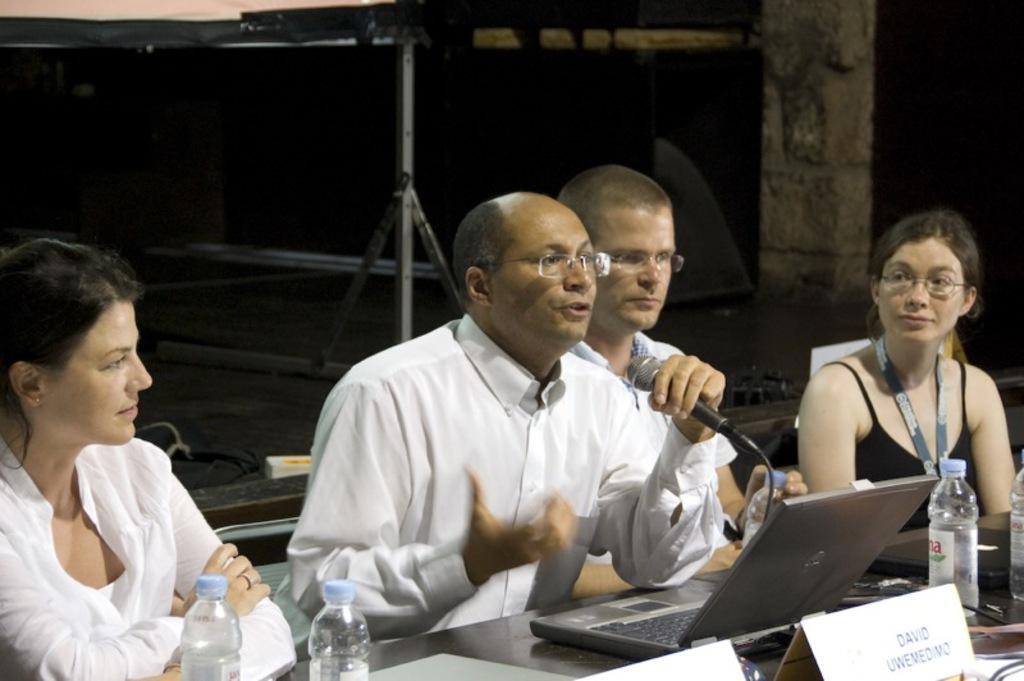Could you give a brief overview of what you see in this image? In this picture, we see four people sitting on chair. Among them, two are men and the remaining two are women. The man in the middle wearing white shirt is holding microphone and he is talking on it. He is even wearing spectacles. Woman on the left corner wearing white shirt is looking the man who is talking. Woman on the right corner is wearing ID card. In front of them, we see a table on which laptop, water bottle, name tag is placed on it. 